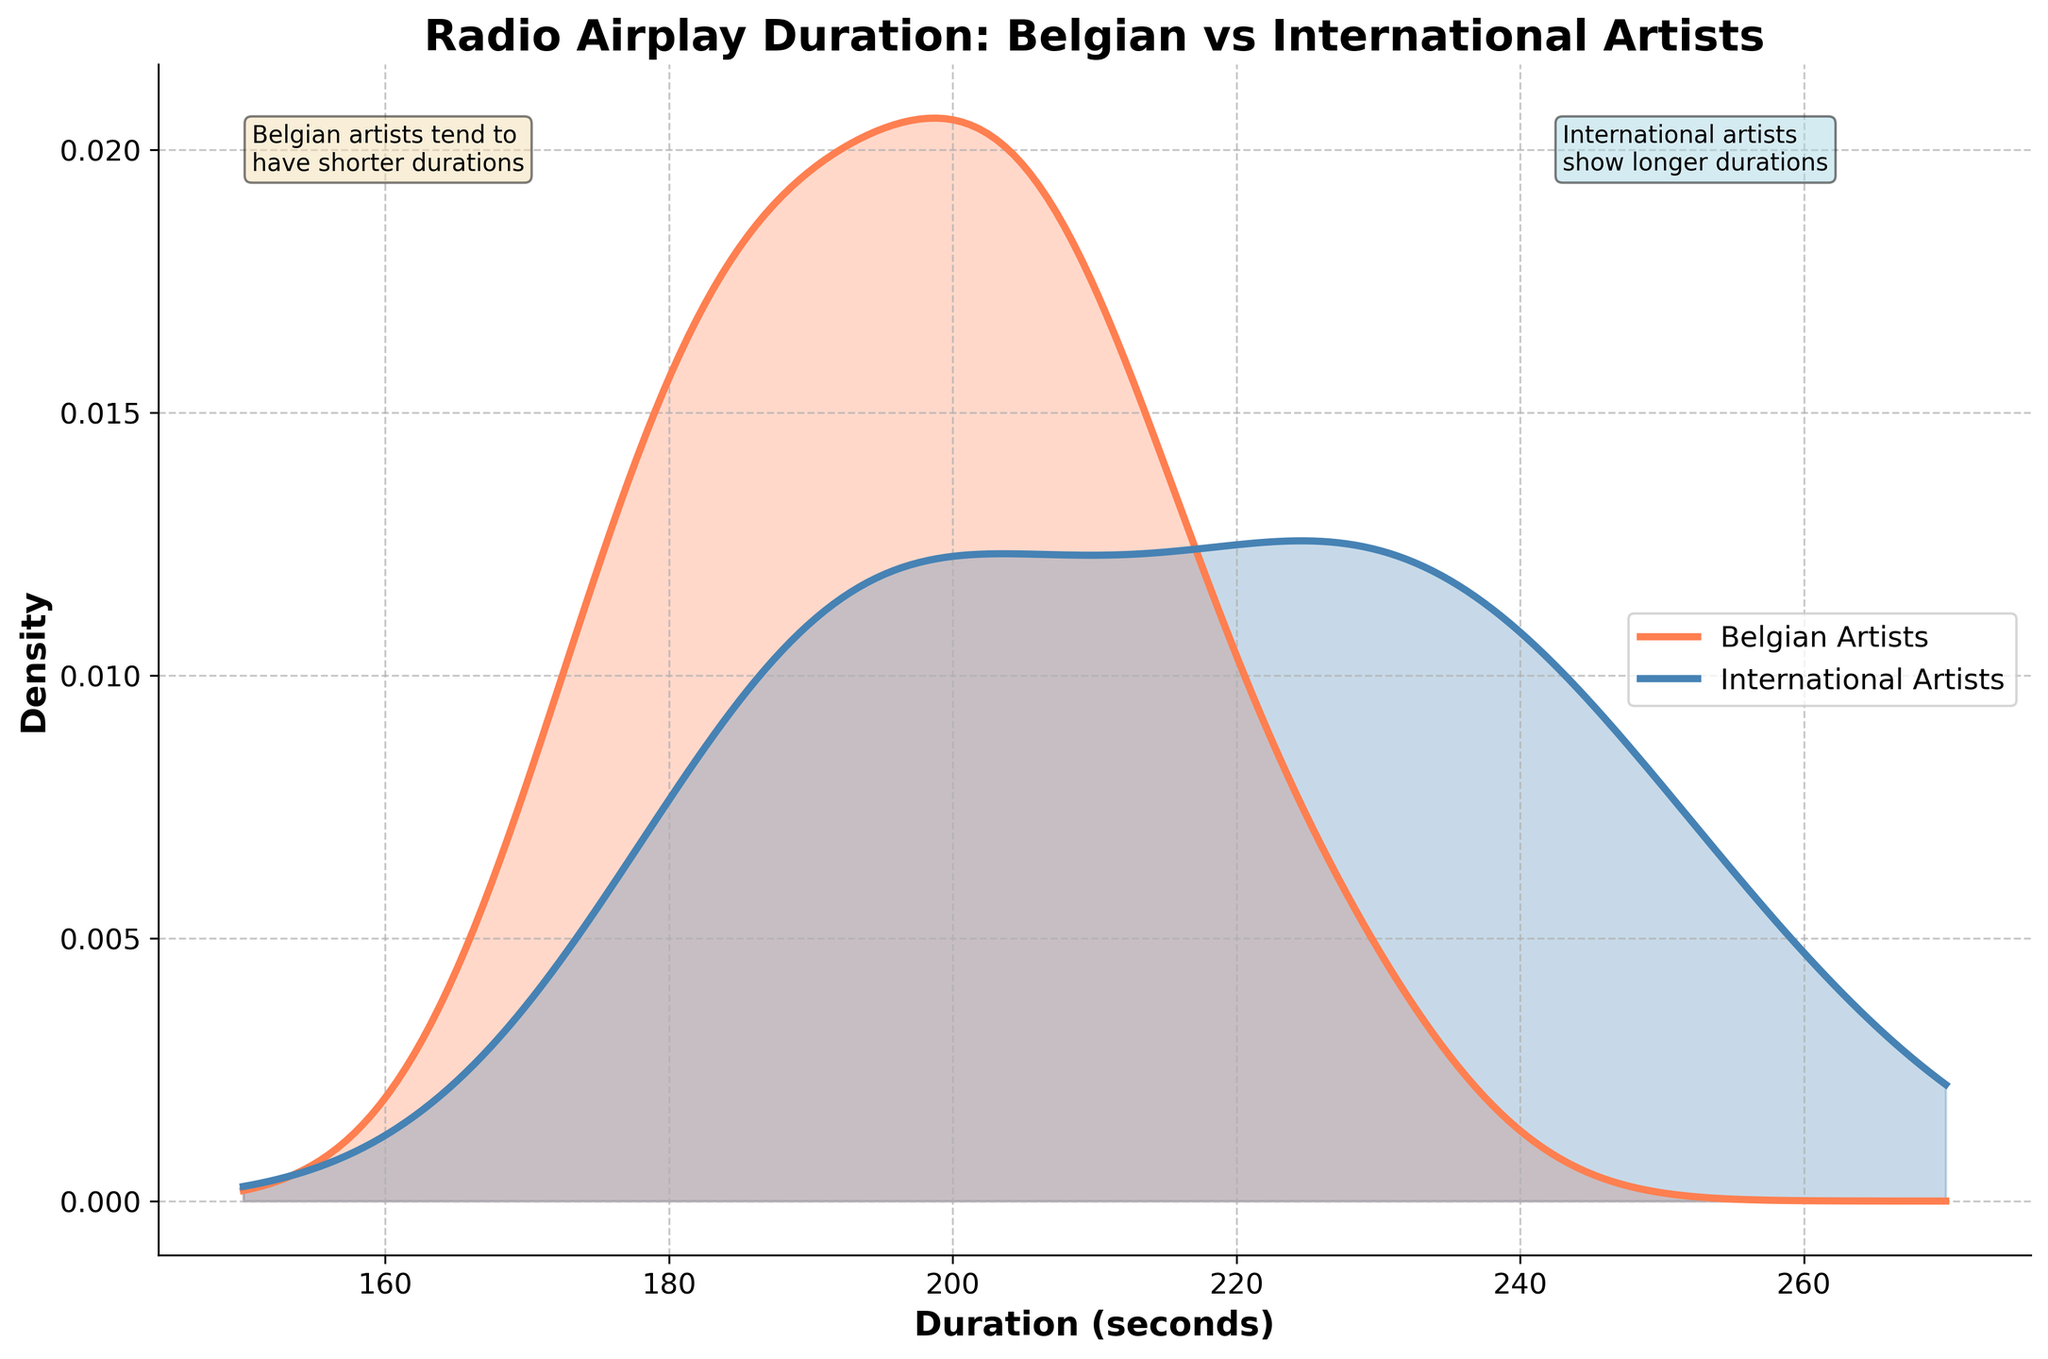What's the title of the plot? The title is located at the top of the plot and summarizes the main focus of the graph, which is the distribution of radio airplay duration for Belgian and International artists.
Answer: Radio Airplay Duration: Belgian vs International Artists What are the units of measurement on the x-axis? The x-axis label indicates the units of measurement which are the duration in seconds for the radio airplay.
Answer: Duration (seconds) Which color represents Belgian artists? The legend on the plot shows that Belgian artists are represented by the color orange.
Answer: Orange Which color represents International artists? The legend on the plot indicates that International artists are represented by the color blue.
Answer: Blue What is the general trend of airplay duration for Belgian artists compared to International artists? Look at the density lines for both Belgian and International artists. Belgian artists' density is higher on the left side of the plot, indicating shorter durations, while the density for International artists is higher on the right side, indicating longer durations.
Answer: Belgian artists have shorter durations; International artists have longer durations At approximately what duration does the density peak for Belgian artists? The peak in the density plot for Belgian artists occurs around the point where the orange line is highest. This looks to be around the 200-second mark.
Answer: Around 200 seconds At approximately what duration does the density peak for International artists? The density peak for International artists is where the blue line is highest. This is around the 220-second mark.
Answer: Around 220 seconds What observation is made about Belgian artists on the plot? The text annotation on the plot mentions that Belgian artists tend to have shorter durations, and it is located near the highest peak of the orange density line.
Answer: Belgian artists tend to have shorter durations What observation is made about International artists on the plot? The text annotation on the plot indicates that International artists show longer durations, and it is located near the peak of the blue density line.
Answer: International artists show longer durations Is there an overlap in the duration distribution between Belgian and International artists? Both orange and blue density lines overlap in certain areas, particularly around the 190 to 220-second region, indicating that there's a range where both Belgian and International artists' durations are similar.
Answer: Yes 